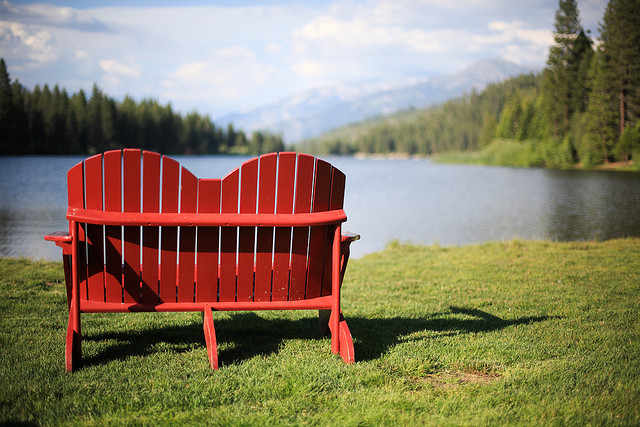Imagine this location as a popular tourist spot. What activities might people do here? As a popular tourist destination, this location offers a wide range of activities for visitors. People might enjoy kayaking or canoeing on the tranquil lake, taking in the splendid views of the surrounding mountains and forest. Fishing enthusiasts would find the lake a perfect spot to catch some local fish. The forest trails around the lake would be great for hiking, providing opportunities to explore the local flora and fauna. Picnickers could spread out near the lake's edge, while photographers would capture the stunning scenery. In the evenings, tourists might gather around a campfire, sharing stories and enjoying the starry sky. The red bench would remain a favorite spot for couples and friends to sit and enjoy the serene atmosphere, making memories that last a lifetime. 